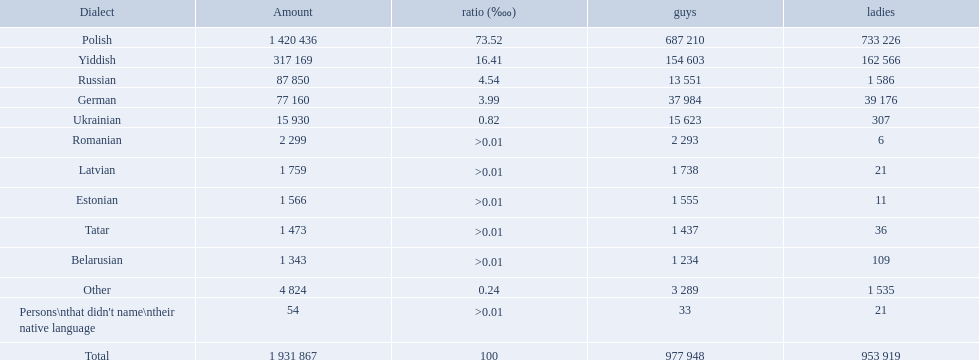What are the languages of the warsaw governorate? Polish, Yiddish, Russian, German, Ukrainian, Romanian, Latvian, Estonian, Tatar, Belarusian, Other. What is the percentage of polish? 73.52. What is the next highest amount? 16.41. What is the language with this amount? Yiddish. What is the percentage of polish speakers? 73.52. What is the next highest percentage of speakers? 16.41. What language is this percentage? Yiddish. What languages are spoken in the warsaw governorate? Polish, Yiddish, Russian, German, Ukrainian, Romanian, Latvian, Estonian, Tatar, Belarusian. Which are the top five languages? Polish, Yiddish, Russian, German, Ukrainian. Of those which is the 2nd most frequently spoken? Yiddish. What were all the languages? Polish, Yiddish, Russian, German, Ukrainian, Romanian, Latvian, Estonian, Tatar, Belarusian, Other, Persons\nthat didn't name\ntheir native language. For these, how many people spoke them? 1 420 436, 317 169, 87 850, 77 160, 15 930, 2 299, 1 759, 1 566, 1 473, 1 343, 4 824, 54. Of these, which is the largest number of speakers? 1 420 436. Which language corresponds to this number? Polish. What are all the languages? Polish, Yiddish, Russian, German, Ukrainian, Romanian, Latvian, Estonian, Tatar, Belarusian, Other. Which only have percentages >0.01? Romanian, Latvian, Estonian, Tatar, Belarusian. Of these, which has the greatest number of speakers? Romanian. Which languages had percentages of >0.01? Romanian, Latvian, Estonian, Tatar, Belarusian. What was the top language? Romanian. What languages are spoken in the warsaw governorate? Polish, Yiddish, Russian, German, Ukrainian, Romanian, Latvian, Estonian, Tatar, Belarusian, Other, Persons\nthat didn't name\ntheir native language. What is the number for russian? 87 850. On this list what is the next lowest number? 77 160. Which language has a number of 77160 speakers? German. 